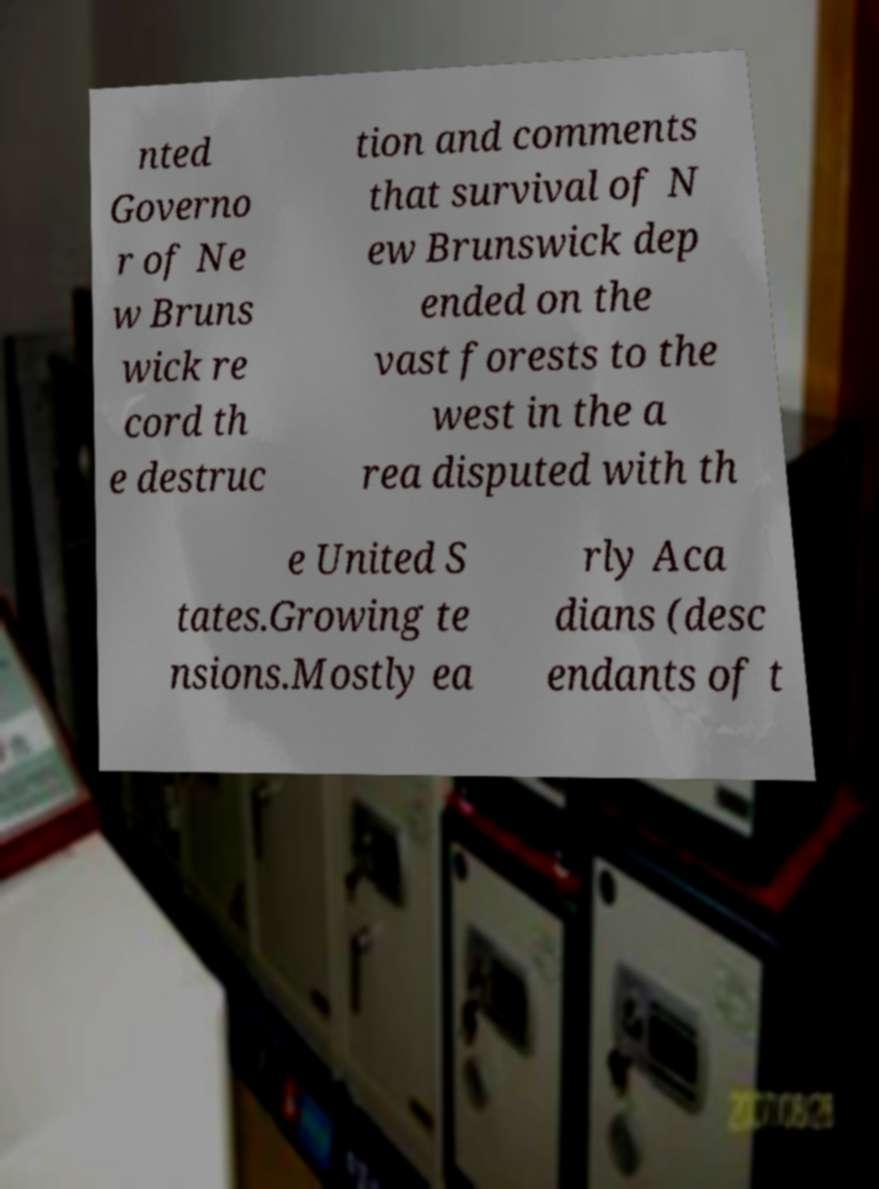There's text embedded in this image that I need extracted. Can you transcribe it verbatim? nted Governo r of Ne w Bruns wick re cord th e destruc tion and comments that survival of N ew Brunswick dep ended on the vast forests to the west in the a rea disputed with th e United S tates.Growing te nsions.Mostly ea rly Aca dians (desc endants of t 